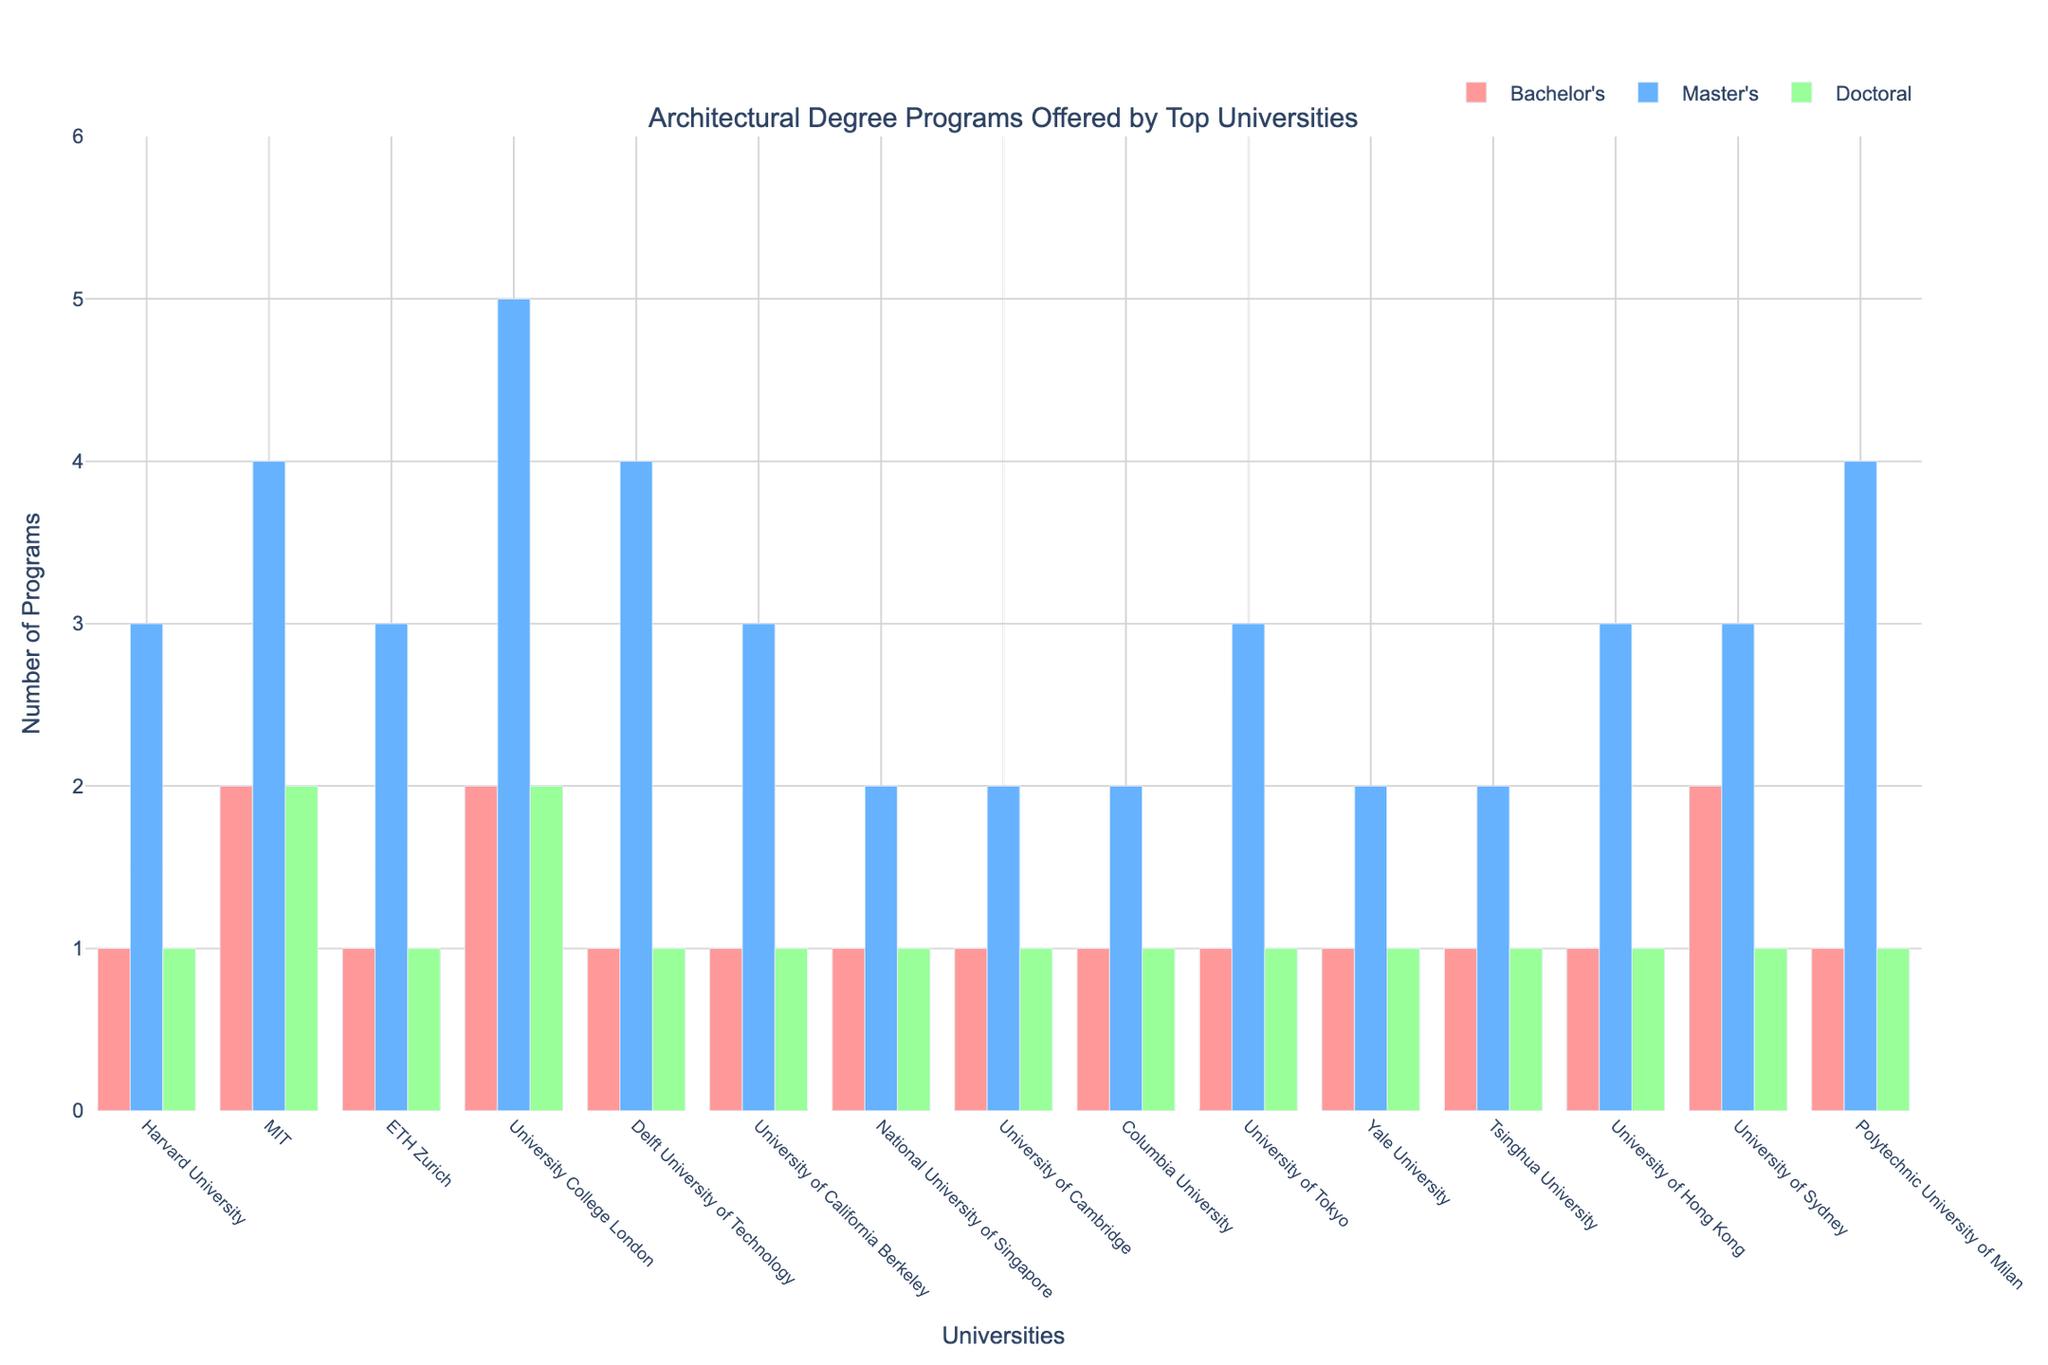Which university offers the highest number of master's degree programs? Look for the university with the tallest blue bar representing master's degree. University College London has the tallest blue bar with 5 programs.
Answer: University College London Which universities offer exactly 1 bachelor’s degree program? Look for the red bars with a height corresponding to 1 and note the associated universities. These universities are Harvard University, ETH Zurich, Delft University of Technology, University of California Berkeley, National University of Singapore, University of Cambridge, Columbia University, University of Tokyo, Yale University, Tsinghua University, University of Hong Kong, and Polytechnic University of Milan.
Answer: Harvard University, ETH Zurich, Delft University of Technology, University of California Berkeley, National University of Singapore, University of Cambridge, Columbia University, University of Tokyo, Yale University, Tsinghua University, University of Hong Kong, Polytechnic University of Milan Which two universities offer the same number of doctoral degree programs? Observe the green bars representing doctoral programs to find universities with equal bar heights. MIT and University College London both have green bars of height 2, indicating they offer 2 doctoral programs each.
Answer: MIT and University College London What is the total number of architectural degree programs offered by Yale University? Sum the heights of all bars (Bachelor's, Master's, Doctoral) corresponding to Yale University. Yale offers 1 bachelor's, 2 master's, and 1 doctoral program, equating to 1 + 2 + 1 = 4 programs.
Answer: 4 How many more master's programs does MIT offer compared to National University of Singapore? Compare heights of the blue bars for MIT and National University of Singapore. MIT offers 4 master's while National University of Singapore offers 2, so the difference is 4 - 2 = 2.
Answer: 2 Which university offers the most balanced distribution of degree programs across all levels? Look for a university with relatively equal heights for red, blue, and green bars. Harvard University's bars are relatively equal with 1 bachelor's, 3 master's, and 1 doctoral program.
Answer: Harvard University Which university offers the fewest master's degree programs but provides all three degree levels? Look for universities with total blue bars at the minimal level while still having red and green bars. National University of Singapore and University of Cambridge both, sharing the lowest with 2 master's programs, but offering bachelor's and doctoral as well.
Answer: National University of Singapore, University of Cambridge Compare the number of bachelor's degree programs at University College London and University of Sydney. Which university offers more? Compare the heights of the red bars for University College London and University of Sydney. Both universities offer 2 bachelor's degree programs.
Answer: Equal; both offer 2 programs How many total doctoral programs are offered by all universities combined? Sum the heights of all green bars. Each university has 1 doctoral program, except MIT and University College London which have 2 each. The total is 12 (1 each from 12 universities) + 2 (MIT) + 2 (University College London) = 16.
Answer: 16 